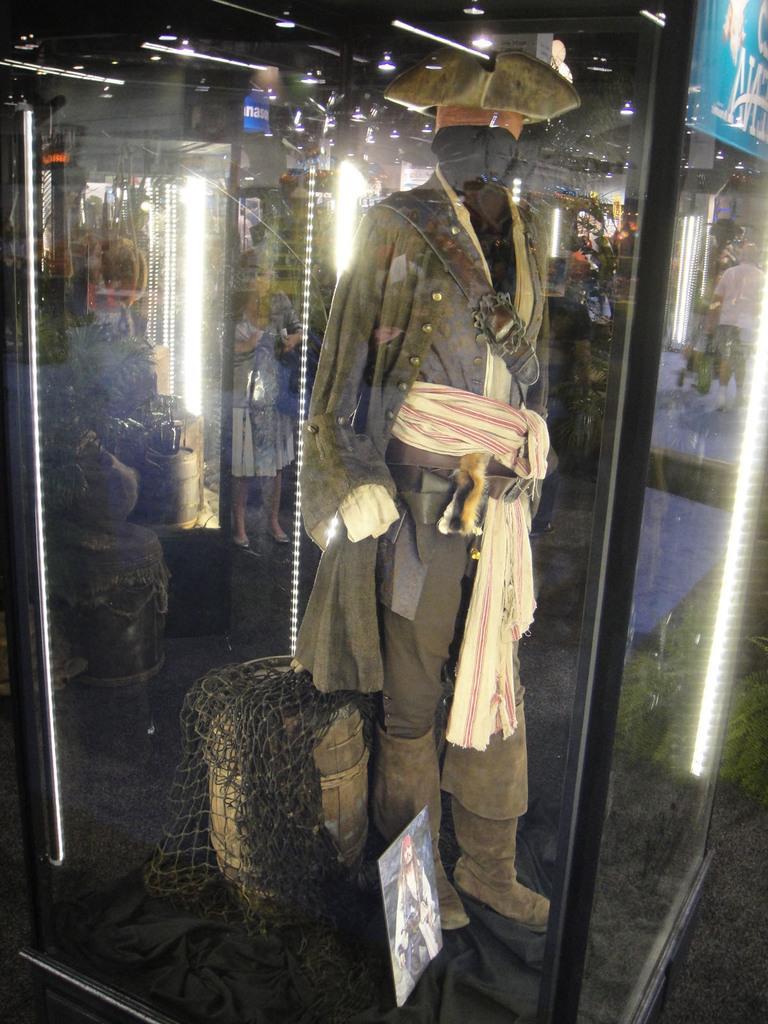What is the main object in the image? There is a mannequin in the image. What else can be seen in the image besides the mannequin? There is a barrel with a net in the image. How are the barrel and net displayed in the image? The barrel and net are kept in a glass container. What is the mannequin wearing in the image? There are many clothes on the mannequin. How many spiders are crawling on the queen in the image? There is no queen or spiders present in the image. What type of string is used to hold the mannequin's clothes together in the image? There is no string used to hold the mannequin's clothes together in the image; the clothes are simply placed on the mannequin. 